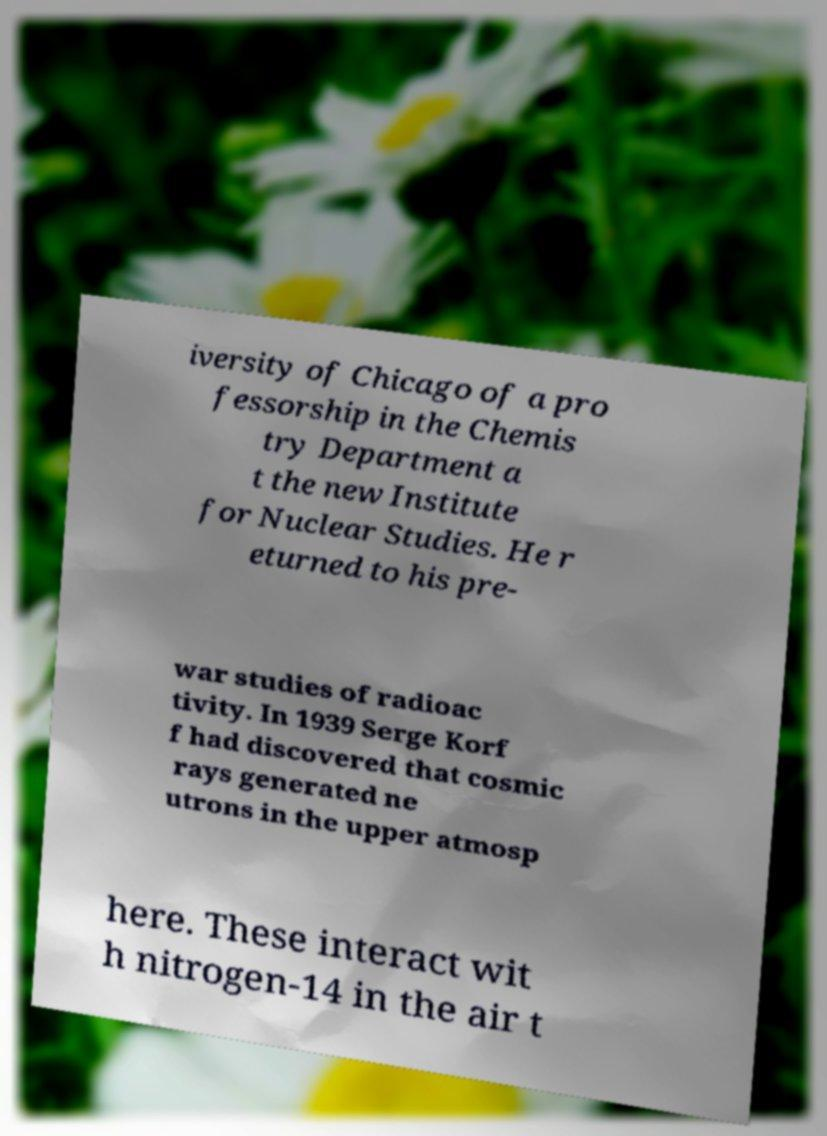What messages or text are displayed in this image? I need them in a readable, typed format. iversity of Chicago of a pro fessorship in the Chemis try Department a t the new Institute for Nuclear Studies. He r eturned to his pre- war studies of radioac tivity. In 1939 Serge Korf f had discovered that cosmic rays generated ne utrons in the upper atmosp here. These interact wit h nitrogen-14 in the air t 